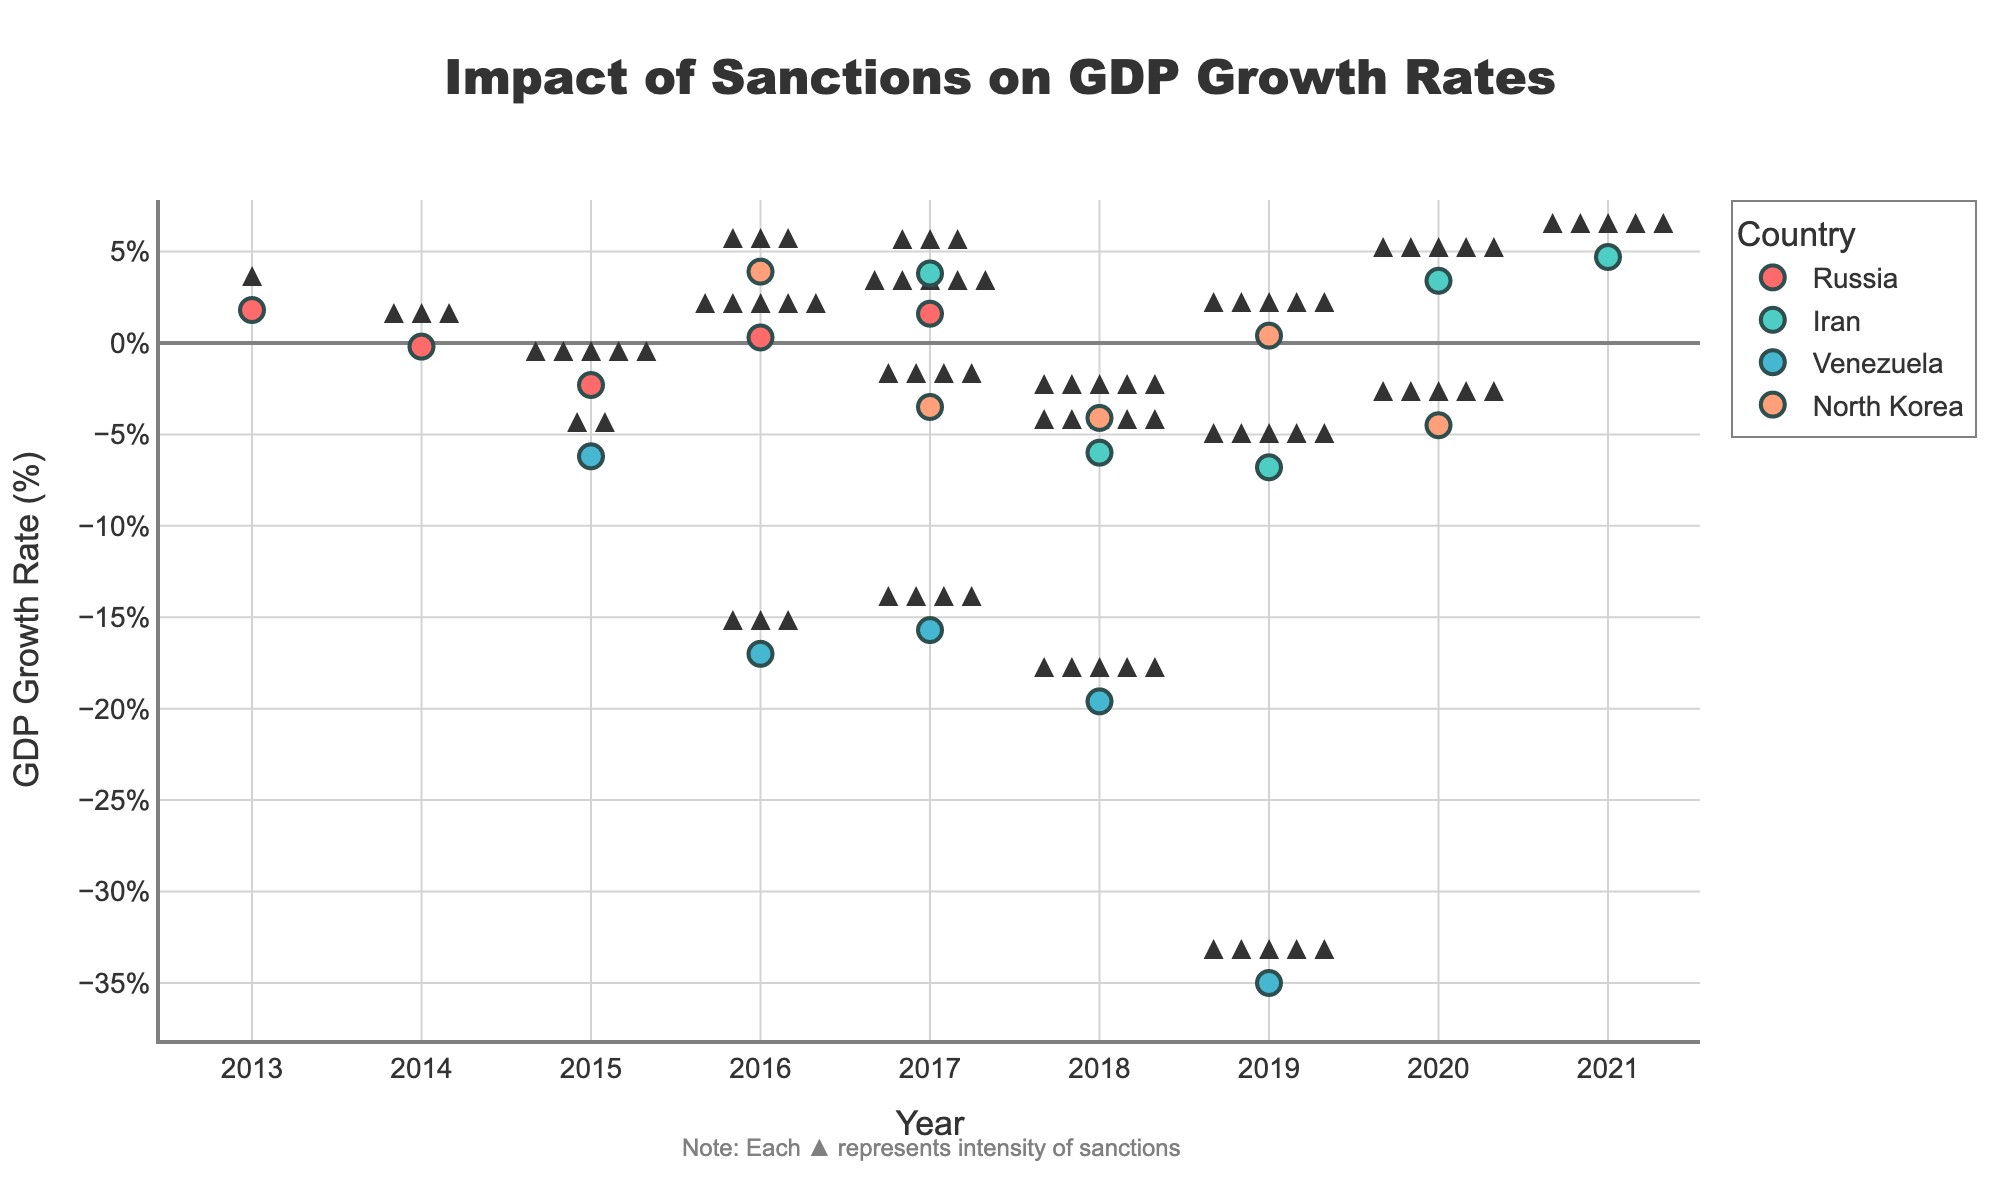What is the title of the figure? The title of the figure is located at the top, centered and in large font. It reads, "Impact of Sanctions on GDP Growth Rates".
Answer: Impact of Sanctions on GDP Growth Rates Which country experienced the largest negative GDP growth rate and in which year? The largest negative GDP growth rate can be identified by finding the lowest point on the y-axis. This occurs for Venezuela in the year 2019 with a GDP growth rate of -35.0%.
Answer: Venezuela, 2019 How many countries are represented in the figure, and what are they? The legend on the right-hand side of the figure lists the countries represented. The four countries are Russia, Iran, Venezuela, and North Korea.
Answer: Four (Russia, Iran, Venezuela, North Korea) For Russia, how many years did it experience negative GDP growth rates, and during which years? Looking at Russia's points, negative GDP growth is visible below the 0% line on the y-axis for the years 2014 and 2015.
Answer: Two years (2014, 2015) What is the average GDP growth rate for Iran over the years presented? The GDP growth rates for Iran from 2017 to 2021 are 3.8, -6.0, -6.8, 3.4, and 4.7. Summing these values (3.8 - 6.0 - 6.8 + 3.4 + 4.7 = -0.9) and then dividing by the number of years (5) results in -0.18.
Answer: -0.18% Which country had the most consistent levels of sanctions (same number of icons) from the given data, and what number of icons did they have? By counting the number of icons for each year per country, it is clear that Iran had a consistent number (5 icons) from 2018 to 2021.
Answer: Iran (5 icons) Compare the GDP growth rate trends of North Korea and Venezuela in 2017. Which country experienced a larger decrease? North Korea had a GDP growth rate of -3.5%, and Venezuela had a GDP growth rate of -15.7% in 2017. By comparing these values, Venezuela experienced a significantly larger decrease.
Answer: Venezuela How does the GDP growth rate of Russia change from 2016 to 2017? The GDP growth rate for Russia increases from 0.3% in 2016 to 1.6% in 2017. The change is found by subtracting the earlier value from the later value (1.6 - 0.3 = 1.3).
Answer: Increased by 1.3% Which country shows a positive GDP growth rate immediately after a year with negative GDP growth rate, and in which year does this reversal occur? Reviewing the data for reversals, both North Korea and Iran show this. North Korea moves from -4.1% in 2018 to 0.4% in 2019. Iran moves from -6.8% in 2019 to 3.4% in 2020.
Answer: North Korea (2019), Iran (2020) How many total sanction icons are displayed for Venezuela? Summing the number of sanctions icons for Venezuela in each year (2 in 2015, 3 in 2016, 4 in 2017, 5 in 2018, and 5 in 2019) results in a total of 19 icons.
Answer: 19 icons 